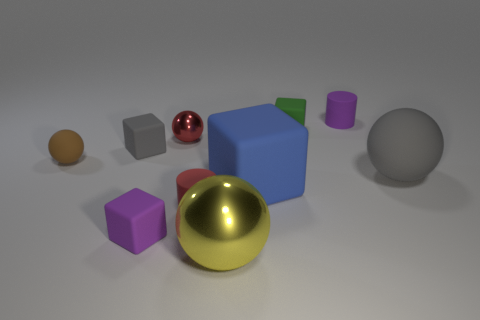What material is the gray object on the right side of the purple cylinder? The gray object appears to be a cube that could be made of plastic or metal, given its smooth surface and sharp edges. It reflects light uniformly, which is typical for materials with even textures. 